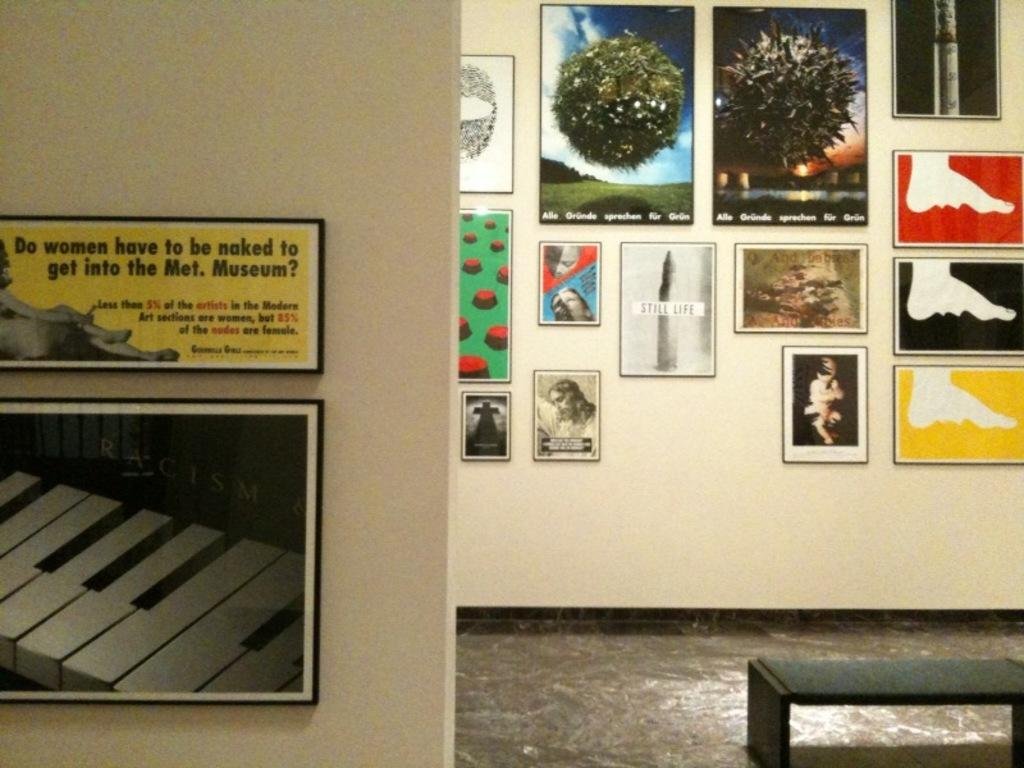Where are the posters located in the image? The posters are on the right side and the left side of the image. What can be inferred about the location of the posters in the image? The posters are on the wall, as they are attached to it. What type of toothpaste is advertised on the posters in the image? There is no toothpaste advertised on the posters in the image, as the provided facts do not mention any specific products or advertisements. 